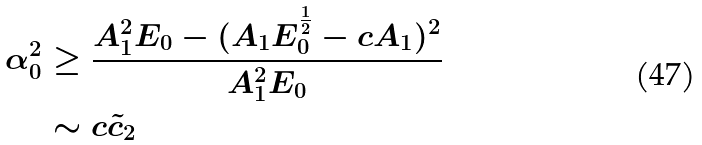Convert formula to latex. <formula><loc_0><loc_0><loc_500><loc_500>\alpha _ { 0 } ^ { 2 } & \geq \frac { A _ { 1 } ^ { 2 } E _ { 0 } - ( A _ { 1 } E _ { 0 } ^ { \frac { 1 } { 2 } } - c A _ { 1 } ) ^ { 2 } } { A _ { 1 } ^ { 2 } E _ { 0 } } \\ & \sim c \tilde { c } _ { 2 }</formula> 